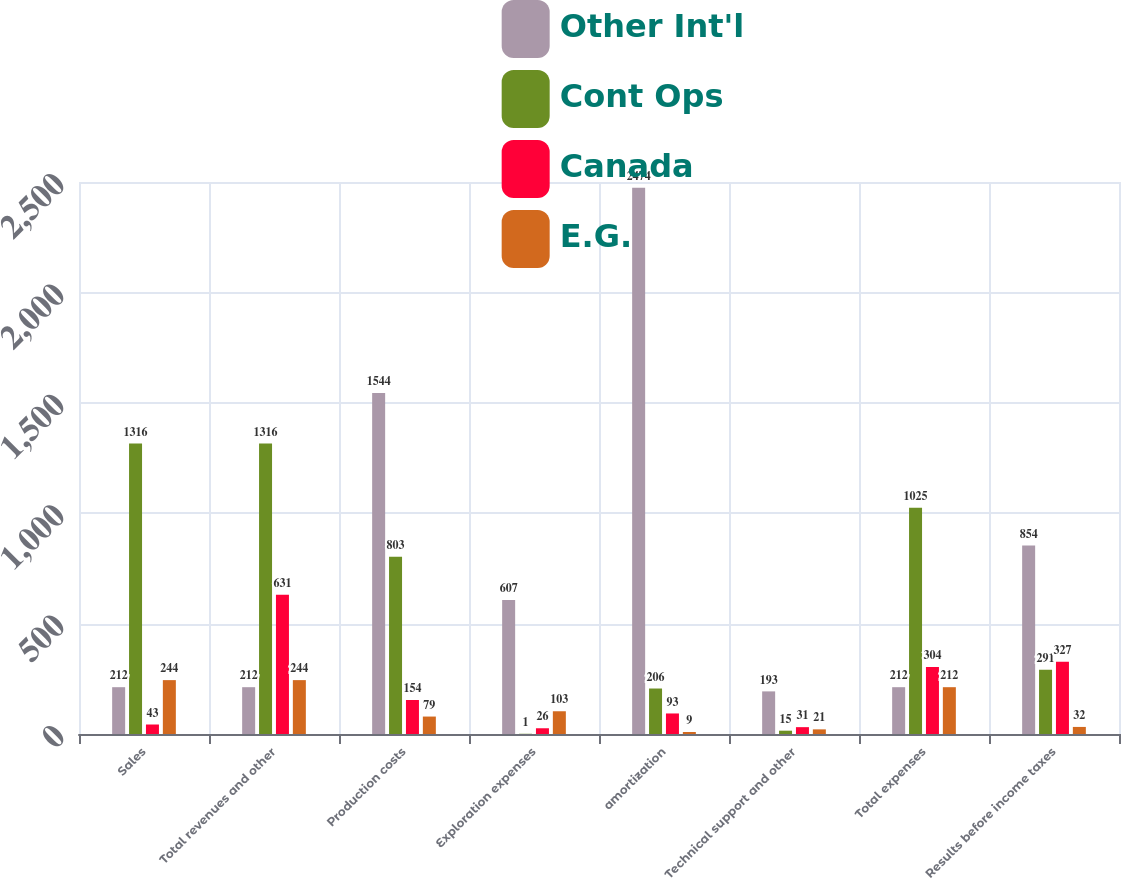<chart> <loc_0><loc_0><loc_500><loc_500><stacked_bar_chart><ecel><fcel>Sales<fcel>Total revenues and other<fcel>Production costs<fcel>Exploration expenses<fcel>amortization<fcel>Technical support and other<fcel>Total expenses<fcel>Results before income taxes<nl><fcel>Other Int'l<fcel>212<fcel>212<fcel>1544<fcel>607<fcel>2474<fcel>193<fcel>212<fcel>854<nl><fcel>Cont Ops<fcel>1316<fcel>1316<fcel>803<fcel>1<fcel>206<fcel>15<fcel>1025<fcel>291<nl><fcel>Canada<fcel>43<fcel>631<fcel>154<fcel>26<fcel>93<fcel>31<fcel>304<fcel>327<nl><fcel>E.G.<fcel>244<fcel>244<fcel>79<fcel>103<fcel>9<fcel>21<fcel>212<fcel>32<nl></chart> 